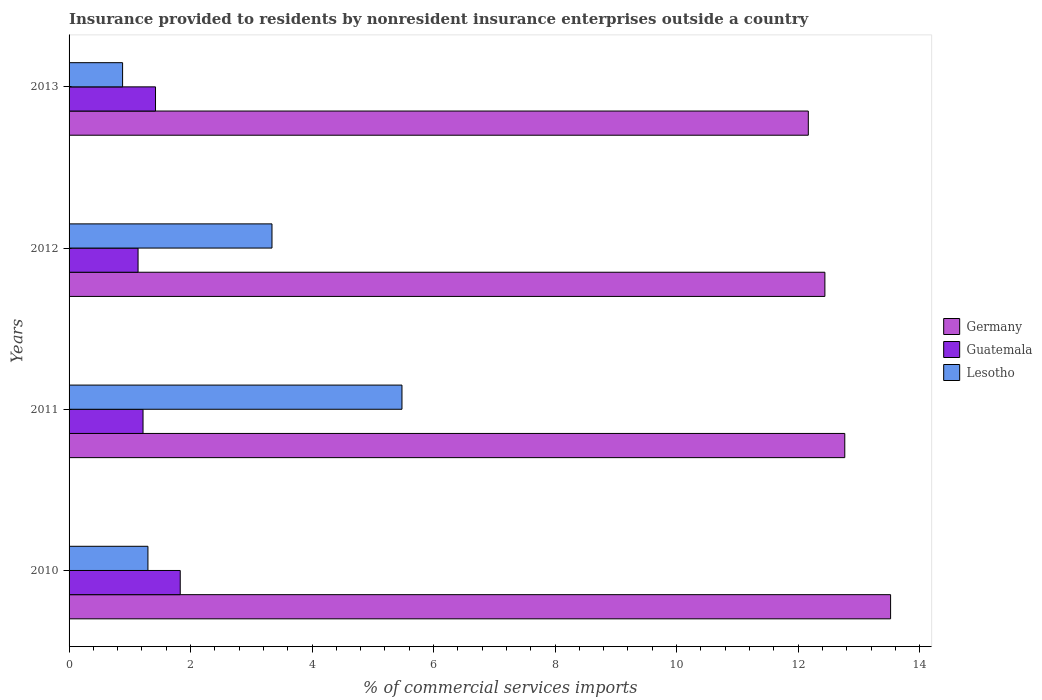Are the number of bars on each tick of the Y-axis equal?
Offer a very short reply. Yes. How many bars are there on the 1st tick from the top?
Offer a terse response. 3. What is the label of the 1st group of bars from the top?
Provide a succinct answer. 2013. What is the Insurance provided to residents in Germany in 2011?
Offer a terse response. 12.77. Across all years, what is the maximum Insurance provided to residents in Lesotho?
Your answer should be compact. 5.48. Across all years, what is the minimum Insurance provided to residents in Lesotho?
Your answer should be very brief. 0.88. What is the total Insurance provided to residents in Guatemala in the graph?
Give a very brief answer. 5.61. What is the difference between the Insurance provided to residents in Guatemala in 2012 and that in 2013?
Your response must be concise. -0.29. What is the difference between the Insurance provided to residents in Germany in 2010 and the Insurance provided to residents in Lesotho in 2011?
Make the answer very short. 8.04. What is the average Insurance provided to residents in Lesotho per year?
Give a very brief answer. 2.75. In the year 2010, what is the difference between the Insurance provided to residents in Lesotho and Insurance provided to residents in Germany?
Offer a terse response. -12.22. In how many years, is the Insurance provided to residents in Lesotho greater than 10.8 %?
Your answer should be compact. 0. What is the ratio of the Insurance provided to residents in Germany in 2011 to that in 2012?
Make the answer very short. 1.03. What is the difference between the highest and the second highest Insurance provided to residents in Lesotho?
Give a very brief answer. 2.14. What is the difference between the highest and the lowest Insurance provided to residents in Lesotho?
Provide a succinct answer. 4.6. In how many years, is the Insurance provided to residents in Guatemala greater than the average Insurance provided to residents in Guatemala taken over all years?
Your response must be concise. 2. Is the sum of the Insurance provided to residents in Lesotho in 2011 and 2012 greater than the maximum Insurance provided to residents in Germany across all years?
Make the answer very short. No. What does the 3rd bar from the bottom in 2010 represents?
Provide a succinct answer. Lesotho. What is the difference between two consecutive major ticks on the X-axis?
Your answer should be very brief. 2. Are the values on the major ticks of X-axis written in scientific E-notation?
Ensure brevity in your answer.  No. Does the graph contain grids?
Give a very brief answer. No. Where does the legend appear in the graph?
Your answer should be very brief. Center right. How many legend labels are there?
Offer a terse response. 3. How are the legend labels stacked?
Give a very brief answer. Vertical. What is the title of the graph?
Your response must be concise. Insurance provided to residents by nonresident insurance enterprises outside a country. Does "Malawi" appear as one of the legend labels in the graph?
Offer a very short reply. No. What is the label or title of the X-axis?
Give a very brief answer. % of commercial services imports. What is the label or title of the Y-axis?
Make the answer very short. Years. What is the % of commercial services imports in Germany in 2010?
Offer a very short reply. 13.52. What is the % of commercial services imports in Guatemala in 2010?
Provide a short and direct response. 1.83. What is the % of commercial services imports in Lesotho in 2010?
Ensure brevity in your answer.  1.3. What is the % of commercial services imports of Germany in 2011?
Keep it short and to the point. 12.77. What is the % of commercial services imports of Guatemala in 2011?
Provide a short and direct response. 1.22. What is the % of commercial services imports of Lesotho in 2011?
Your answer should be very brief. 5.48. What is the % of commercial services imports in Germany in 2012?
Your answer should be compact. 12.44. What is the % of commercial services imports in Guatemala in 2012?
Provide a short and direct response. 1.14. What is the % of commercial services imports of Lesotho in 2012?
Offer a terse response. 3.34. What is the % of commercial services imports of Germany in 2013?
Keep it short and to the point. 12.17. What is the % of commercial services imports of Guatemala in 2013?
Give a very brief answer. 1.42. What is the % of commercial services imports in Lesotho in 2013?
Your response must be concise. 0.88. Across all years, what is the maximum % of commercial services imports of Germany?
Make the answer very short. 13.52. Across all years, what is the maximum % of commercial services imports of Guatemala?
Your response must be concise. 1.83. Across all years, what is the maximum % of commercial services imports in Lesotho?
Provide a short and direct response. 5.48. Across all years, what is the minimum % of commercial services imports of Germany?
Provide a short and direct response. 12.17. Across all years, what is the minimum % of commercial services imports of Guatemala?
Your answer should be compact. 1.14. Across all years, what is the minimum % of commercial services imports of Lesotho?
Your response must be concise. 0.88. What is the total % of commercial services imports in Germany in the graph?
Make the answer very short. 50.9. What is the total % of commercial services imports of Guatemala in the graph?
Provide a short and direct response. 5.61. What is the total % of commercial services imports of Lesotho in the graph?
Give a very brief answer. 11. What is the difference between the % of commercial services imports of Germany in 2010 and that in 2011?
Your response must be concise. 0.75. What is the difference between the % of commercial services imports of Guatemala in 2010 and that in 2011?
Ensure brevity in your answer.  0.61. What is the difference between the % of commercial services imports in Lesotho in 2010 and that in 2011?
Your answer should be compact. -4.18. What is the difference between the % of commercial services imports of Germany in 2010 and that in 2012?
Give a very brief answer. 1.08. What is the difference between the % of commercial services imports in Guatemala in 2010 and that in 2012?
Provide a succinct answer. 0.69. What is the difference between the % of commercial services imports of Lesotho in 2010 and that in 2012?
Give a very brief answer. -2.04. What is the difference between the % of commercial services imports in Germany in 2010 and that in 2013?
Your answer should be compact. 1.35. What is the difference between the % of commercial services imports in Guatemala in 2010 and that in 2013?
Your answer should be very brief. 0.41. What is the difference between the % of commercial services imports of Lesotho in 2010 and that in 2013?
Offer a very short reply. 0.42. What is the difference between the % of commercial services imports of Germany in 2011 and that in 2012?
Your answer should be compact. 0.33. What is the difference between the % of commercial services imports of Guatemala in 2011 and that in 2012?
Your answer should be very brief. 0.08. What is the difference between the % of commercial services imports in Lesotho in 2011 and that in 2012?
Offer a very short reply. 2.14. What is the difference between the % of commercial services imports of Germany in 2011 and that in 2013?
Give a very brief answer. 0.6. What is the difference between the % of commercial services imports of Guatemala in 2011 and that in 2013?
Offer a very short reply. -0.21. What is the difference between the % of commercial services imports of Lesotho in 2011 and that in 2013?
Ensure brevity in your answer.  4.6. What is the difference between the % of commercial services imports of Germany in 2012 and that in 2013?
Your response must be concise. 0.27. What is the difference between the % of commercial services imports in Guatemala in 2012 and that in 2013?
Keep it short and to the point. -0.29. What is the difference between the % of commercial services imports in Lesotho in 2012 and that in 2013?
Offer a very short reply. 2.46. What is the difference between the % of commercial services imports in Germany in 2010 and the % of commercial services imports in Guatemala in 2011?
Provide a short and direct response. 12.31. What is the difference between the % of commercial services imports of Germany in 2010 and the % of commercial services imports of Lesotho in 2011?
Make the answer very short. 8.04. What is the difference between the % of commercial services imports of Guatemala in 2010 and the % of commercial services imports of Lesotho in 2011?
Ensure brevity in your answer.  -3.65. What is the difference between the % of commercial services imports in Germany in 2010 and the % of commercial services imports in Guatemala in 2012?
Your answer should be compact. 12.39. What is the difference between the % of commercial services imports of Germany in 2010 and the % of commercial services imports of Lesotho in 2012?
Your response must be concise. 10.18. What is the difference between the % of commercial services imports in Guatemala in 2010 and the % of commercial services imports in Lesotho in 2012?
Your answer should be very brief. -1.51. What is the difference between the % of commercial services imports of Germany in 2010 and the % of commercial services imports of Guatemala in 2013?
Your answer should be compact. 12.1. What is the difference between the % of commercial services imports of Germany in 2010 and the % of commercial services imports of Lesotho in 2013?
Offer a terse response. 12.64. What is the difference between the % of commercial services imports of Guatemala in 2010 and the % of commercial services imports of Lesotho in 2013?
Offer a terse response. 0.95. What is the difference between the % of commercial services imports in Germany in 2011 and the % of commercial services imports in Guatemala in 2012?
Your answer should be compact. 11.63. What is the difference between the % of commercial services imports of Germany in 2011 and the % of commercial services imports of Lesotho in 2012?
Your answer should be compact. 9.43. What is the difference between the % of commercial services imports in Guatemala in 2011 and the % of commercial services imports in Lesotho in 2012?
Provide a succinct answer. -2.12. What is the difference between the % of commercial services imports of Germany in 2011 and the % of commercial services imports of Guatemala in 2013?
Your response must be concise. 11.35. What is the difference between the % of commercial services imports in Germany in 2011 and the % of commercial services imports in Lesotho in 2013?
Offer a terse response. 11.89. What is the difference between the % of commercial services imports in Guatemala in 2011 and the % of commercial services imports in Lesotho in 2013?
Offer a very short reply. 0.34. What is the difference between the % of commercial services imports of Germany in 2012 and the % of commercial services imports of Guatemala in 2013?
Provide a short and direct response. 11.02. What is the difference between the % of commercial services imports in Germany in 2012 and the % of commercial services imports in Lesotho in 2013?
Ensure brevity in your answer.  11.56. What is the difference between the % of commercial services imports of Guatemala in 2012 and the % of commercial services imports of Lesotho in 2013?
Make the answer very short. 0.25. What is the average % of commercial services imports of Germany per year?
Make the answer very short. 12.72. What is the average % of commercial services imports in Guatemala per year?
Your answer should be very brief. 1.4. What is the average % of commercial services imports in Lesotho per year?
Offer a terse response. 2.75. In the year 2010, what is the difference between the % of commercial services imports in Germany and % of commercial services imports in Guatemala?
Keep it short and to the point. 11.69. In the year 2010, what is the difference between the % of commercial services imports of Germany and % of commercial services imports of Lesotho?
Keep it short and to the point. 12.22. In the year 2010, what is the difference between the % of commercial services imports in Guatemala and % of commercial services imports in Lesotho?
Your answer should be very brief. 0.53. In the year 2011, what is the difference between the % of commercial services imports of Germany and % of commercial services imports of Guatemala?
Provide a succinct answer. 11.55. In the year 2011, what is the difference between the % of commercial services imports in Germany and % of commercial services imports in Lesotho?
Your response must be concise. 7.29. In the year 2011, what is the difference between the % of commercial services imports in Guatemala and % of commercial services imports in Lesotho?
Offer a terse response. -4.26. In the year 2012, what is the difference between the % of commercial services imports in Germany and % of commercial services imports in Guatemala?
Ensure brevity in your answer.  11.31. In the year 2012, what is the difference between the % of commercial services imports in Germany and % of commercial services imports in Lesotho?
Provide a short and direct response. 9.1. In the year 2012, what is the difference between the % of commercial services imports of Guatemala and % of commercial services imports of Lesotho?
Your answer should be very brief. -2.2. In the year 2013, what is the difference between the % of commercial services imports of Germany and % of commercial services imports of Guatemala?
Offer a very short reply. 10.75. In the year 2013, what is the difference between the % of commercial services imports of Germany and % of commercial services imports of Lesotho?
Provide a succinct answer. 11.29. In the year 2013, what is the difference between the % of commercial services imports in Guatemala and % of commercial services imports in Lesotho?
Offer a terse response. 0.54. What is the ratio of the % of commercial services imports of Germany in 2010 to that in 2011?
Keep it short and to the point. 1.06. What is the ratio of the % of commercial services imports of Guatemala in 2010 to that in 2011?
Offer a very short reply. 1.5. What is the ratio of the % of commercial services imports in Lesotho in 2010 to that in 2011?
Give a very brief answer. 0.24. What is the ratio of the % of commercial services imports of Germany in 2010 to that in 2012?
Provide a succinct answer. 1.09. What is the ratio of the % of commercial services imports of Guatemala in 2010 to that in 2012?
Your answer should be compact. 1.61. What is the ratio of the % of commercial services imports of Lesotho in 2010 to that in 2012?
Offer a very short reply. 0.39. What is the ratio of the % of commercial services imports of Germany in 2010 to that in 2013?
Offer a very short reply. 1.11. What is the ratio of the % of commercial services imports in Guatemala in 2010 to that in 2013?
Offer a very short reply. 1.29. What is the ratio of the % of commercial services imports of Lesotho in 2010 to that in 2013?
Offer a very short reply. 1.47. What is the ratio of the % of commercial services imports in Germany in 2011 to that in 2012?
Give a very brief answer. 1.03. What is the ratio of the % of commercial services imports in Guatemala in 2011 to that in 2012?
Your answer should be compact. 1.07. What is the ratio of the % of commercial services imports of Lesotho in 2011 to that in 2012?
Provide a short and direct response. 1.64. What is the ratio of the % of commercial services imports of Germany in 2011 to that in 2013?
Your answer should be compact. 1.05. What is the ratio of the % of commercial services imports in Guatemala in 2011 to that in 2013?
Your answer should be compact. 0.86. What is the ratio of the % of commercial services imports in Lesotho in 2011 to that in 2013?
Provide a succinct answer. 6.22. What is the ratio of the % of commercial services imports of Germany in 2012 to that in 2013?
Make the answer very short. 1.02. What is the ratio of the % of commercial services imports of Guatemala in 2012 to that in 2013?
Keep it short and to the point. 0.8. What is the ratio of the % of commercial services imports of Lesotho in 2012 to that in 2013?
Your answer should be very brief. 3.79. What is the difference between the highest and the second highest % of commercial services imports in Germany?
Offer a very short reply. 0.75. What is the difference between the highest and the second highest % of commercial services imports of Guatemala?
Offer a very short reply. 0.41. What is the difference between the highest and the second highest % of commercial services imports of Lesotho?
Keep it short and to the point. 2.14. What is the difference between the highest and the lowest % of commercial services imports in Germany?
Your answer should be very brief. 1.35. What is the difference between the highest and the lowest % of commercial services imports of Guatemala?
Your response must be concise. 0.69. What is the difference between the highest and the lowest % of commercial services imports in Lesotho?
Keep it short and to the point. 4.6. 